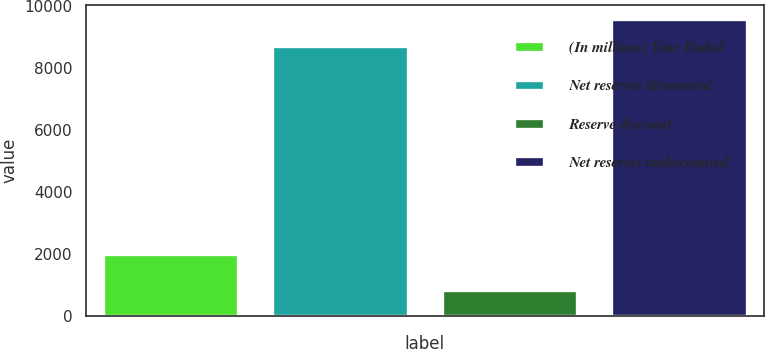Convert chart. <chart><loc_0><loc_0><loc_500><loc_500><bar_chart><fcel>(In millions) Year Ended<fcel>Net reserves discounted<fcel>Reserve discount<fcel>Net reserves undiscounted<nl><fcel>2013<fcel>8684<fcel>837<fcel>9552.4<nl></chart> 